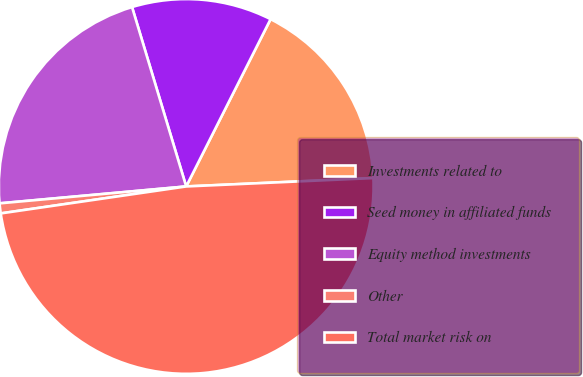Convert chart to OTSL. <chart><loc_0><loc_0><loc_500><loc_500><pie_chart><fcel>Investments related to<fcel>Seed money in affiliated funds<fcel>Equity method investments<fcel>Other<fcel>Total market risk on<nl><fcel>16.85%<fcel>12.1%<fcel>21.77%<fcel>0.86%<fcel>48.41%<nl></chart> 